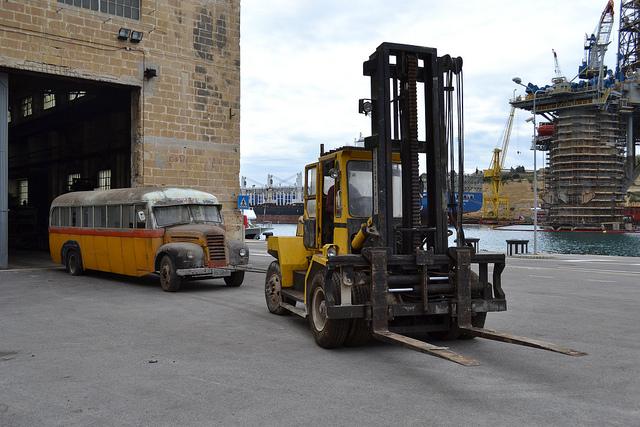Is it daytime?
Be succinct. Yes. Why are patches of paint missing from the bus?
Write a very short answer. Rust. What is in front of the bus?
Concise answer only. Forklift. 